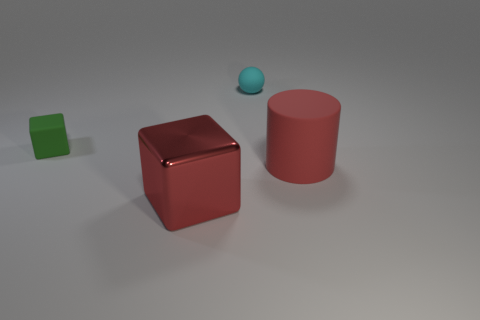Add 1 purple blocks. How many objects exist? 5 Subtract all cylinders. How many objects are left? 3 Add 4 green matte things. How many green matte things exist? 5 Subtract 0 brown cylinders. How many objects are left? 4 Subtract all big cyan cylinders. Subtract all tiny cyan matte objects. How many objects are left? 3 Add 4 big metallic objects. How many big metallic objects are left? 5 